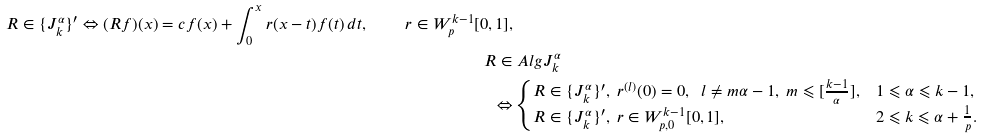<formula> <loc_0><loc_0><loc_500><loc_500>R \in \{ J _ { k } ^ { \alpha } \} ^ { \prime } \Leftrightarrow ( R f ) ( x ) = c f ( x ) + \int _ { 0 } ^ { x } r ( x - t ) f ( t ) \, d t , \quad r \in W _ { p } ^ { k - 1 } [ 0 , 1 ] , \\ R \in & \ A l g J _ { k } ^ { \alpha } \\ \Leftrightarrow & \begin{cases} R \in \{ J _ { k } ^ { \alpha } \} ^ { \prime } , \ r ^ { ( l ) } ( 0 ) = 0 , \ \ l \ne m \alpha - 1 , \ m \leqslant [ \frac { k - 1 } { \alpha } ] , & 1 \leqslant \alpha \leqslant k - 1 , \\ R \in \{ J _ { k } ^ { \alpha } \} ^ { \prime } , \ r \in W _ { p , 0 } ^ { k - 1 } [ 0 , 1 ] , & 2 \leqslant k \leqslant \alpha + \frac { 1 } { p } . \end{cases}</formula> 